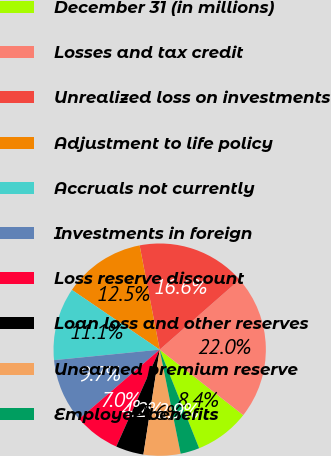<chart> <loc_0><loc_0><loc_500><loc_500><pie_chart><fcel>December 31 (in millions)<fcel>Losses and tax credit<fcel>Unrealized loss on investments<fcel>Adjustment to life policy<fcel>Accruals not currently<fcel>Investments in foreign<fcel>Loss reserve discount<fcel>Loan loss and other reserves<fcel>Unearned premium reserve<fcel>Employee benefits<nl><fcel>8.36%<fcel>22.04%<fcel>16.57%<fcel>12.46%<fcel>11.09%<fcel>9.73%<fcel>6.99%<fcel>4.25%<fcel>5.62%<fcel>2.89%<nl></chart> 